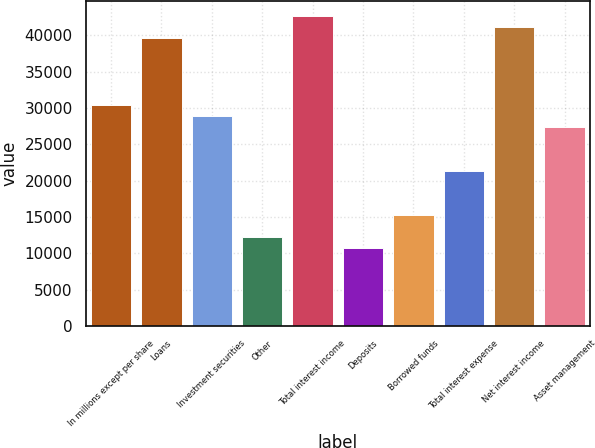Convert chart. <chart><loc_0><loc_0><loc_500><loc_500><bar_chart><fcel>In millions except per share<fcel>Loans<fcel>Investment securities<fcel>Other<fcel>Total interest income<fcel>Deposits<fcel>Borrowed funds<fcel>Total interest expense<fcel>Net interest income<fcel>Asset management<nl><fcel>30445<fcel>39577<fcel>28923<fcel>12181<fcel>42621<fcel>10659<fcel>15225<fcel>21313<fcel>41099<fcel>27401<nl></chart> 